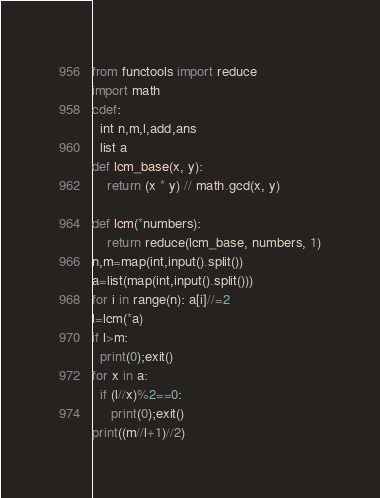Convert code to text. <code><loc_0><loc_0><loc_500><loc_500><_Cython_>from functools import reduce
import math
cdef:
  int n,m,l,add,ans
  list a
def lcm_base(x, y):
    return (x * y) // math.gcd(x, y)

def lcm(*numbers):
    return reduce(lcm_base, numbers, 1)
n,m=map(int,input().split())
a=list(map(int,input().split()))
for i in range(n): a[i]//=2
l=lcm(*a)
if l>m:
  print(0);exit()
for x in a:
  if (l//x)%2==0:
     print(0);exit()
print((m//l+1)//2)</code> 